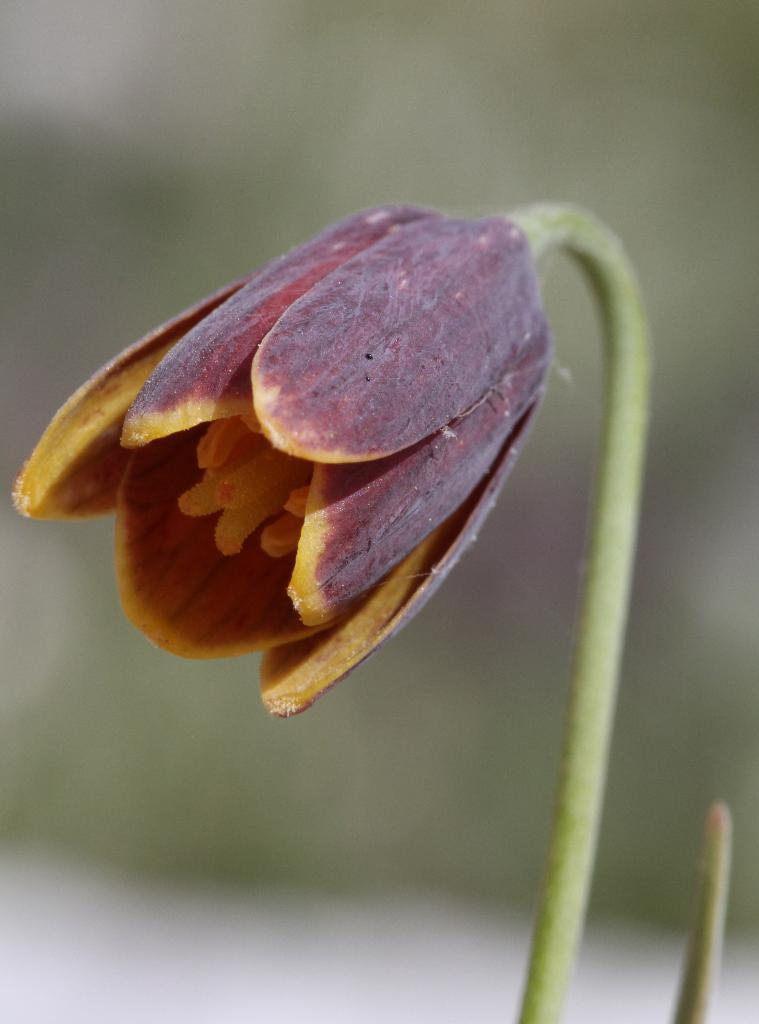What is present in the image? There is a plant in the image. What specific feature of the plant can be observed? The plant has a flower. What colors are present in the flower? The flower has a brown and yellow color combination. What else can be seen in the background of the image? There are other objects in the background of the image. Is there a girl holding a pancake in the image? No, there is no girl or pancake present in the image. The image only features a plant with a flower and other unspecified objects in the background. 